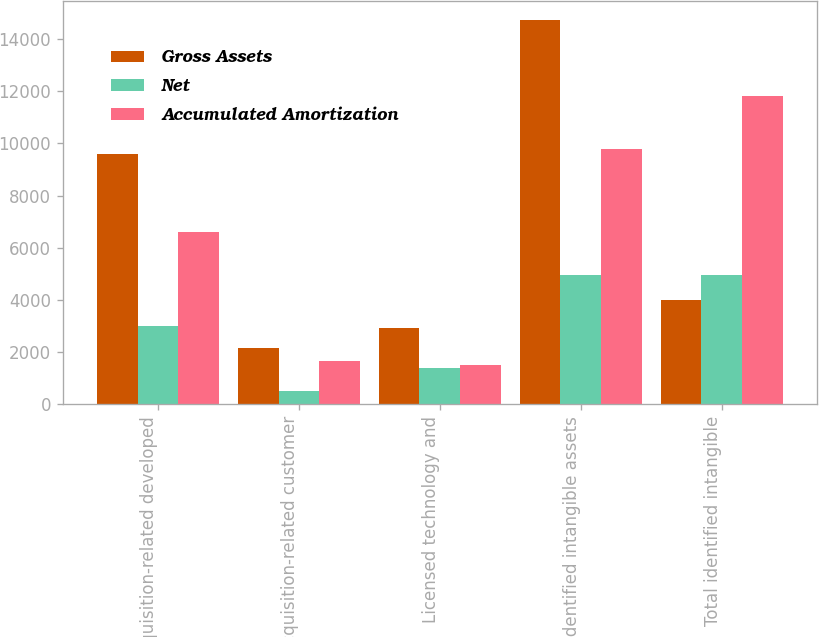<chart> <loc_0><loc_0><loc_500><loc_500><stacked_bar_chart><ecel><fcel>Acquisition-related developed<fcel>Acquisition-related customer<fcel>Licensed technology and<fcel>Identified intangible assets<fcel>Total identified intangible<nl><fcel>Gross Assets<fcel>9611<fcel>2179<fcel>2932<fcel>14722<fcel>3987.5<nl><fcel>Net<fcel>3021<fcel>527<fcel>1406<fcel>4954<fcel>4954<nl><fcel>Accumulated Amortization<fcel>6590<fcel>1652<fcel>1526<fcel>9768<fcel>11836<nl></chart> 